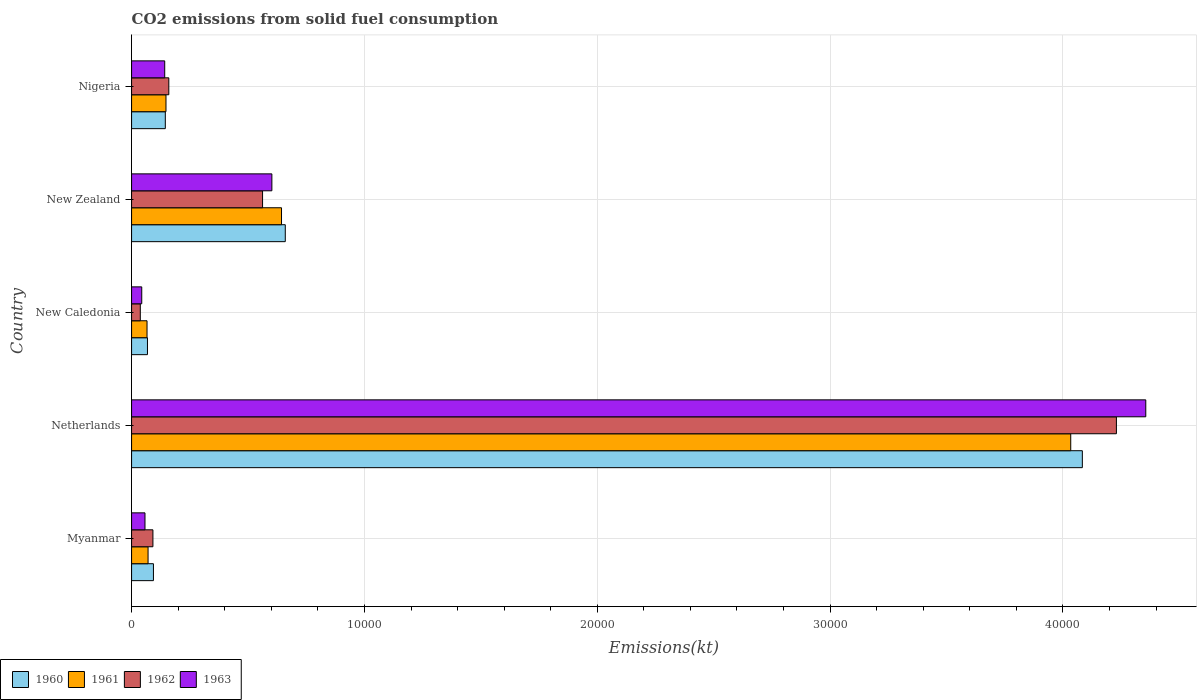How many groups of bars are there?
Keep it short and to the point. 5. How many bars are there on the 4th tick from the top?
Offer a very short reply. 4. What is the label of the 5th group of bars from the top?
Make the answer very short. Myanmar. In how many cases, is the number of bars for a given country not equal to the number of legend labels?
Offer a terse response. 0. What is the amount of CO2 emitted in 1961 in Nigeria?
Offer a very short reply. 1477.8. Across all countries, what is the maximum amount of CO2 emitted in 1963?
Your answer should be very brief. 4.36e+04. Across all countries, what is the minimum amount of CO2 emitted in 1960?
Make the answer very short. 682.06. In which country was the amount of CO2 emitted in 1962 maximum?
Offer a very short reply. Netherlands. In which country was the amount of CO2 emitted in 1960 minimum?
Make the answer very short. New Caledonia. What is the total amount of CO2 emitted in 1961 in the graph?
Give a very brief answer. 4.96e+04. What is the difference between the amount of CO2 emitted in 1962 in New Caledonia and that in New Zealand?
Provide a short and direct response. -5251.14. What is the difference between the amount of CO2 emitted in 1961 in Netherlands and the amount of CO2 emitted in 1960 in New Caledonia?
Ensure brevity in your answer.  3.97e+04. What is the average amount of CO2 emitted in 1961 per country?
Ensure brevity in your answer.  9924.37. What is the difference between the amount of CO2 emitted in 1962 and amount of CO2 emitted in 1961 in New Zealand?
Offer a terse response. -814.07. What is the ratio of the amount of CO2 emitted in 1961 in Netherlands to that in Nigeria?
Keep it short and to the point. 27.29. What is the difference between the highest and the second highest amount of CO2 emitted in 1961?
Your answer should be compact. 3.39e+04. What is the difference between the highest and the lowest amount of CO2 emitted in 1961?
Your answer should be very brief. 3.97e+04. In how many countries, is the amount of CO2 emitted in 1962 greater than the average amount of CO2 emitted in 1962 taken over all countries?
Make the answer very short. 1. Is the sum of the amount of CO2 emitted in 1960 in Netherlands and Nigeria greater than the maximum amount of CO2 emitted in 1961 across all countries?
Provide a short and direct response. Yes. Is it the case that in every country, the sum of the amount of CO2 emitted in 1963 and amount of CO2 emitted in 1960 is greater than the sum of amount of CO2 emitted in 1962 and amount of CO2 emitted in 1961?
Offer a very short reply. No. What does the 3rd bar from the bottom in New Zealand represents?
Give a very brief answer. 1962. What is the difference between two consecutive major ticks on the X-axis?
Ensure brevity in your answer.  10000. Does the graph contain any zero values?
Give a very brief answer. No. Where does the legend appear in the graph?
Your answer should be very brief. Bottom left. What is the title of the graph?
Make the answer very short. CO2 emissions from solid fuel consumption. Does "1987" appear as one of the legend labels in the graph?
Make the answer very short. No. What is the label or title of the X-axis?
Your answer should be very brief. Emissions(kt). What is the Emissions(kt) of 1960 in Myanmar?
Your response must be concise. 938.75. What is the Emissions(kt) in 1961 in Myanmar?
Ensure brevity in your answer.  707.73. What is the Emissions(kt) in 1962 in Myanmar?
Offer a very short reply. 916.75. What is the Emissions(kt) of 1963 in Myanmar?
Ensure brevity in your answer.  575.72. What is the Emissions(kt) in 1960 in Netherlands?
Keep it short and to the point. 4.08e+04. What is the Emissions(kt) in 1961 in Netherlands?
Make the answer very short. 4.03e+04. What is the Emissions(kt) of 1962 in Netherlands?
Your answer should be very brief. 4.23e+04. What is the Emissions(kt) in 1963 in Netherlands?
Your answer should be compact. 4.36e+04. What is the Emissions(kt) in 1960 in New Caledonia?
Provide a succinct answer. 682.06. What is the Emissions(kt) of 1961 in New Caledonia?
Offer a terse response. 663.73. What is the Emissions(kt) of 1962 in New Caledonia?
Keep it short and to the point. 374.03. What is the Emissions(kt) in 1963 in New Caledonia?
Your answer should be compact. 436.37. What is the Emissions(kt) of 1960 in New Zealand?
Provide a short and direct response. 6600.6. What is the Emissions(kt) in 1961 in New Zealand?
Your answer should be compact. 6439.25. What is the Emissions(kt) in 1962 in New Zealand?
Keep it short and to the point. 5625.18. What is the Emissions(kt) of 1963 in New Zealand?
Your answer should be compact. 6024.88. What is the Emissions(kt) in 1960 in Nigeria?
Give a very brief answer. 1448.46. What is the Emissions(kt) of 1961 in Nigeria?
Your response must be concise. 1477.8. What is the Emissions(kt) of 1962 in Nigeria?
Give a very brief answer. 1598.81. What is the Emissions(kt) of 1963 in Nigeria?
Give a very brief answer. 1422.8. Across all countries, what is the maximum Emissions(kt) in 1960?
Your response must be concise. 4.08e+04. Across all countries, what is the maximum Emissions(kt) in 1961?
Provide a short and direct response. 4.03e+04. Across all countries, what is the maximum Emissions(kt) of 1962?
Your response must be concise. 4.23e+04. Across all countries, what is the maximum Emissions(kt) of 1963?
Your answer should be compact. 4.36e+04. Across all countries, what is the minimum Emissions(kt) of 1960?
Offer a very short reply. 682.06. Across all countries, what is the minimum Emissions(kt) in 1961?
Provide a succinct answer. 663.73. Across all countries, what is the minimum Emissions(kt) in 1962?
Give a very brief answer. 374.03. Across all countries, what is the minimum Emissions(kt) in 1963?
Offer a very short reply. 436.37. What is the total Emissions(kt) of 1960 in the graph?
Keep it short and to the point. 5.05e+04. What is the total Emissions(kt) of 1961 in the graph?
Make the answer very short. 4.96e+04. What is the total Emissions(kt) of 1962 in the graph?
Give a very brief answer. 5.08e+04. What is the total Emissions(kt) in 1963 in the graph?
Provide a succinct answer. 5.20e+04. What is the difference between the Emissions(kt) of 1960 in Myanmar and that in Netherlands?
Ensure brevity in your answer.  -3.99e+04. What is the difference between the Emissions(kt) in 1961 in Myanmar and that in Netherlands?
Your answer should be compact. -3.96e+04. What is the difference between the Emissions(kt) of 1962 in Myanmar and that in Netherlands?
Offer a very short reply. -4.14e+04. What is the difference between the Emissions(kt) in 1963 in Myanmar and that in Netherlands?
Give a very brief answer. -4.30e+04. What is the difference between the Emissions(kt) of 1960 in Myanmar and that in New Caledonia?
Provide a succinct answer. 256.69. What is the difference between the Emissions(kt) of 1961 in Myanmar and that in New Caledonia?
Your answer should be compact. 44. What is the difference between the Emissions(kt) in 1962 in Myanmar and that in New Caledonia?
Your response must be concise. 542.72. What is the difference between the Emissions(kt) of 1963 in Myanmar and that in New Caledonia?
Provide a succinct answer. 139.35. What is the difference between the Emissions(kt) of 1960 in Myanmar and that in New Zealand?
Your answer should be very brief. -5661.85. What is the difference between the Emissions(kt) of 1961 in Myanmar and that in New Zealand?
Give a very brief answer. -5731.52. What is the difference between the Emissions(kt) in 1962 in Myanmar and that in New Zealand?
Make the answer very short. -4708.43. What is the difference between the Emissions(kt) of 1963 in Myanmar and that in New Zealand?
Your response must be concise. -5449.16. What is the difference between the Emissions(kt) in 1960 in Myanmar and that in Nigeria?
Keep it short and to the point. -509.71. What is the difference between the Emissions(kt) of 1961 in Myanmar and that in Nigeria?
Keep it short and to the point. -770.07. What is the difference between the Emissions(kt) in 1962 in Myanmar and that in Nigeria?
Keep it short and to the point. -682.06. What is the difference between the Emissions(kt) in 1963 in Myanmar and that in Nigeria?
Give a very brief answer. -847.08. What is the difference between the Emissions(kt) of 1960 in Netherlands and that in New Caledonia?
Ensure brevity in your answer.  4.01e+04. What is the difference between the Emissions(kt) in 1961 in Netherlands and that in New Caledonia?
Offer a terse response. 3.97e+04. What is the difference between the Emissions(kt) of 1962 in Netherlands and that in New Caledonia?
Give a very brief answer. 4.19e+04. What is the difference between the Emissions(kt) of 1963 in Netherlands and that in New Caledonia?
Your answer should be very brief. 4.31e+04. What is the difference between the Emissions(kt) in 1960 in Netherlands and that in New Zealand?
Provide a succinct answer. 3.42e+04. What is the difference between the Emissions(kt) in 1961 in Netherlands and that in New Zealand?
Your response must be concise. 3.39e+04. What is the difference between the Emissions(kt) in 1962 in Netherlands and that in New Zealand?
Your answer should be compact. 3.67e+04. What is the difference between the Emissions(kt) of 1963 in Netherlands and that in New Zealand?
Keep it short and to the point. 3.75e+04. What is the difference between the Emissions(kt) of 1960 in Netherlands and that in Nigeria?
Your answer should be compact. 3.94e+04. What is the difference between the Emissions(kt) in 1961 in Netherlands and that in Nigeria?
Give a very brief answer. 3.89e+04. What is the difference between the Emissions(kt) of 1962 in Netherlands and that in Nigeria?
Ensure brevity in your answer.  4.07e+04. What is the difference between the Emissions(kt) in 1963 in Netherlands and that in Nigeria?
Your response must be concise. 4.21e+04. What is the difference between the Emissions(kt) of 1960 in New Caledonia and that in New Zealand?
Your response must be concise. -5918.54. What is the difference between the Emissions(kt) in 1961 in New Caledonia and that in New Zealand?
Provide a short and direct response. -5775.52. What is the difference between the Emissions(kt) in 1962 in New Caledonia and that in New Zealand?
Make the answer very short. -5251.14. What is the difference between the Emissions(kt) of 1963 in New Caledonia and that in New Zealand?
Your answer should be compact. -5588.51. What is the difference between the Emissions(kt) of 1960 in New Caledonia and that in Nigeria?
Offer a very short reply. -766.4. What is the difference between the Emissions(kt) of 1961 in New Caledonia and that in Nigeria?
Keep it short and to the point. -814.07. What is the difference between the Emissions(kt) in 1962 in New Caledonia and that in Nigeria?
Your answer should be very brief. -1224.78. What is the difference between the Emissions(kt) of 1963 in New Caledonia and that in Nigeria?
Provide a short and direct response. -986.42. What is the difference between the Emissions(kt) in 1960 in New Zealand and that in Nigeria?
Provide a succinct answer. 5152.14. What is the difference between the Emissions(kt) of 1961 in New Zealand and that in Nigeria?
Keep it short and to the point. 4961.45. What is the difference between the Emissions(kt) in 1962 in New Zealand and that in Nigeria?
Ensure brevity in your answer.  4026.37. What is the difference between the Emissions(kt) of 1963 in New Zealand and that in Nigeria?
Ensure brevity in your answer.  4602.09. What is the difference between the Emissions(kt) of 1960 in Myanmar and the Emissions(kt) of 1961 in Netherlands?
Give a very brief answer. -3.94e+04. What is the difference between the Emissions(kt) in 1960 in Myanmar and the Emissions(kt) in 1962 in Netherlands?
Make the answer very short. -4.14e+04. What is the difference between the Emissions(kt) of 1960 in Myanmar and the Emissions(kt) of 1963 in Netherlands?
Provide a succinct answer. -4.26e+04. What is the difference between the Emissions(kt) in 1961 in Myanmar and the Emissions(kt) in 1962 in Netherlands?
Provide a short and direct response. -4.16e+04. What is the difference between the Emissions(kt) in 1961 in Myanmar and the Emissions(kt) in 1963 in Netherlands?
Your answer should be very brief. -4.28e+04. What is the difference between the Emissions(kt) in 1962 in Myanmar and the Emissions(kt) in 1963 in Netherlands?
Provide a succinct answer. -4.26e+04. What is the difference between the Emissions(kt) in 1960 in Myanmar and the Emissions(kt) in 1961 in New Caledonia?
Your answer should be very brief. 275.02. What is the difference between the Emissions(kt) in 1960 in Myanmar and the Emissions(kt) in 1962 in New Caledonia?
Provide a short and direct response. 564.72. What is the difference between the Emissions(kt) of 1960 in Myanmar and the Emissions(kt) of 1963 in New Caledonia?
Give a very brief answer. 502.38. What is the difference between the Emissions(kt) in 1961 in Myanmar and the Emissions(kt) in 1962 in New Caledonia?
Keep it short and to the point. 333.7. What is the difference between the Emissions(kt) of 1961 in Myanmar and the Emissions(kt) of 1963 in New Caledonia?
Make the answer very short. 271.36. What is the difference between the Emissions(kt) in 1962 in Myanmar and the Emissions(kt) in 1963 in New Caledonia?
Give a very brief answer. 480.38. What is the difference between the Emissions(kt) in 1960 in Myanmar and the Emissions(kt) in 1961 in New Zealand?
Keep it short and to the point. -5500.5. What is the difference between the Emissions(kt) of 1960 in Myanmar and the Emissions(kt) of 1962 in New Zealand?
Offer a very short reply. -4686.43. What is the difference between the Emissions(kt) in 1960 in Myanmar and the Emissions(kt) in 1963 in New Zealand?
Your answer should be very brief. -5086.13. What is the difference between the Emissions(kt) in 1961 in Myanmar and the Emissions(kt) in 1962 in New Zealand?
Offer a terse response. -4917.45. What is the difference between the Emissions(kt) in 1961 in Myanmar and the Emissions(kt) in 1963 in New Zealand?
Make the answer very short. -5317.15. What is the difference between the Emissions(kt) of 1962 in Myanmar and the Emissions(kt) of 1963 in New Zealand?
Your answer should be very brief. -5108.13. What is the difference between the Emissions(kt) of 1960 in Myanmar and the Emissions(kt) of 1961 in Nigeria?
Ensure brevity in your answer.  -539.05. What is the difference between the Emissions(kt) of 1960 in Myanmar and the Emissions(kt) of 1962 in Nigeria?
Your answer should be very brief. -660.06. What is the difference between the Emissions(kt) of 1960 in Myanmar and the Emissions(kt) of 1963 in Nigeria?
Your response must be concise. -484.04. What is the difference between the Emissions(kt) of 1961 in Myanmar and the Emissions(kt) of 1962 in Nigeria?
Provide a short and direct response. -891.08. What is the difference between the Emissions(kt) in 1961 in Myanmar and the Emissions(kt) in 1963 in Nigeria?
Keep it short and to the point. -715.07. What is the difference between the Emissions(kt) of 1962 in Myanmar and the Emissions(kt) of 1963 in Nigeria?
Provide a short and direct response. -506.05. What is the difference between the Emissions(kt) in 1960 in Netherlands and the Emissions(kt) in 1961 in New Caledonia?
Make the answer very short. 4.02e+04. What is the difference between the Emissions(kt) in 1960 in Netherlands and the Emissions(kt) in 1962 in New Caledonia?
Your answer should be compact. 4.05e+04. What is the difference between the Emissions(kt) of 1960 in Netherlands and the Emissions(kt) of 1963 in New Caledonia?
Your answer should be very brief. 4.04e+04. What is the difference between the Emissions(kt) of 1961 in Netherlands and the Emissions(kt) of 1962 in New Caledonia?
Offer a terse response. 4.00e+04. What is the difference between the Emissions(kt) in 1961 in Netherlands and the Emissions(kt) in 1963 in New Caledonia?
Your answer should be compact. 3.99e+04. What is the difference between the Emissions(kt) in 1962 in Netherlands and the Emissions(kt) in 1963 in New Caledonia?
Offer a very short reply. 4.19e+04. What is the difference between the Emissions(kt) of 1960 in Netherlands and the Emissions(kt) of 1961 in New Zealand?
Keep it short and to the point. 3.44e+04. What is the difference between the Emissions(kt) of 1960 in Netherlands and the Emissions(kt) of 1962 in New Zealand?
Keep it short and to the point. 3.52e+04. What is the difference between the Emissions(kt) in 1960 in Netherlands and the Emissions(kt) in 1963 in New Zealand?
Your answer should be very brief. 3.48e+04. What is the difference between the Emissions(kt) in 1961 in Netherlands and the Emissions(kt) in 1962 in New Zealand?
Give a very brief answer. 3.47e+04. What is the difference between the Emissions(kt) in 1961 in Netherlands and the Emissions(kt) in 1963 in New Zealand?
Provide a succinct answer. 3.43e+04. What is the difference between the Emissions(kt) of 1962 in Netherlands and the Emissions(kt) of 1963 in New Zealand?
Make the answer very short. 3.63e+04. What is the difference between the Emissions(kt) in 1960 in Netherlands and the Emissions(kt) in 1961 in Nigeria?
Make the answer very short. 3.94e+04. What is the difference between the Emissions(kt) in 1960 in Netherlands and the Emissions(kt) in 1962 in Nigeria?
Ensure brevity in your answer.  3.92e+04. What is the difference between the Emissions(kt) in 1960 in Netherlands and the Emissions(kt) in 1963 in Nigeria?
Make the answer very short. 3.94e+04. What is the difference between the Emissions(kt) of 1961 in Netherlands and the Emissions(kt) of 1962 in Nigeria?
Make the answer very short. 3.87e+04. What is the difference between the Emissions(kt) of 1961 in Netherlands and the Emissions(kt) of 1963 in Nigeria?
Your answer should be very brief. 3.89e+04. What is the difference between the Emissions(kt) of 1962 in Netherlands and the Emissions(kt) of 1963 in Nigeria?
Your answer should be compact. 4.09e+04. What is the difference between the Emissions(kt) in 1960 in New Caledonia and the Emissions(kt) in 1961 in New Zealand?
Keep it short and to the point. -5757.19. What is the difference between the Emissions(kt) of 1960 in New Caledonia and the Emissions(kt) of 1962 in New Zealand?
Your answer should be compact. -4943.12. What is the difference between the Emissions(kt) of 1960 in New Caledonia and the Emissions(kt) of 1963 in New Zealand?
Keep it short and to the point. -5342.82. What is the difference between the Emissions(kt) in 1961 in New Caledonia and the Emissions(kt) in 1962 in New Zealand?
Provide a short and direct response. -4961.45. What is the difference between the Emissions(kt) of 1961 in New Caledonia and the Emissions(kt) of 1963 in New Zealand?
Your answer should be compact. -5361.15. What is the difference between the Emissions(kt) in 1962 in New Caledonia and the Emissions(kt) in 1963 in New Zealand?
Your answer should be compact. -5650.85. What is the difference between the Emissions(kt) in 1960 in New Caledonia and the Emissions(kt) in 1961 in Nigeria?
Offer a terse response. -795.74. What is the difference between the Emissions(kt) of 1960 in New Caledonia and the Emissions(kt) of 1962 in Nigeria?
Give a very brief answer. -916.75. What is the difference between the Emissions(kt) in 1960 in New Caledonia and the Emissions(kt) in 1963 in Nigeria?
Make the answer very short. -740.73. What is the difference between the Emissions(kt) in 1961 in New Caledonia and the Emissions(kt) in 1962 in Nigeria?
Provide a short and direct response. -935.09. What is the difference between the Emissions(kt) in 1961 in New Caledonia and the Emissions(kt) in 1963 in Nigeria?
Offer a terse response. -759.07. What is the difference between the Emissions(kt) in 1962 in New Caledonia and the Emissions(kt) in 1963 in Nigeria?
Offer a very short reply. -1048.76. What is the difference between the Emissions(kt) of 1960 in New Zealand and the Emissions(kt) of 1961 in Nigeria?
Keep it short and to the point. 5122.8. What is the difference between the Emissions(kt) in 1960 in New Zealand and the Emissions(kt) in 1962 in Nigeria?
Your answer should be compact. 5001.79. What is the difference between the Emissions(kt) of 1960 in New Zealand and the Emissions(kt) of 1963 in Nigeria?
Offer a terse response. 5177.8. What is the difference between the Emissions(kt) in 1961 in New Zealand and the Emissions(kt) in 1962 in Nigeria?
Offer a very short reply. 4840.44. What is the difference between the Emissions(kt) in 1961 in New Zealand and the Emissions(kt) in 1963 in Nigeria?
Your answer should be compact. 5016.46. What is the difference between the Emissions(kt) in 1962 in New Zealand and the Emissions(kt) in 1963 in Nigeria?
Your response must be concise. 4202.38. What is the average Emissions(kt) of 1960 per country?
Make the answer very short. 1.01e+04. What is the average Emissions(kt) in 1961 per country?
Ensure brevity in your answer.  9924.37. What is the average Emissions(kt) in 1962 per country?
Offer a terse response. 1.02e+04. What is the average Emissions(kt) of 1963 per country?
Offer a terse response. 1.04e+04. What is the difference between the Emissions(kt) in 1960 and Emissions(kt) in 1961 in Myanmar?
Your answer should be compact. 231.02. What is the difference between the Emissions(kt) in 1960 and Emissions(kt) in 1962 in Myanmar?
Your response must be concise. 22. What is the difference between the Emissions(kt) in 1960 and Emissions(kt) in 1963 in Myanmar?
Your answer should be compact. 363.03. What is the difference between the Emissions(kt) in 1961 and Emissions(kt) in 1962 in Myanmar?
Your answer should be compact. -209.02. What is the difference between the Emissions(kt) of 1961 and Emissions(kt) of 1963 in Myanmar?
Ensure brevity in your answer.  132.01. What is the difference between the Emissions(kt) of 1962 and Emissions(kt) of 1963 in Myanmar?
Ensure brevity in your answer.  341.03. What is the difference between the Emissions(kt) of 1960 and Emissions(kt) of 1961 in Netherlands?
Ensure brevity in your answer.  498.71. What is the difference between the Emissions(kt) in 1960 and Emissions(kt) in 1962 in Netherlands?
Your response must be concise. -1463.13. What is the difference between the Emissions(kt) in 1960 and Emissions(kt) in 1963 in Netherlands?
Give a very brief answer. -2724.58. What is the difference between the Emissions(kt) in 1961 and Emissions(kt) in 1962 in Netherlands?
Ensure brevity in your answer.  -1961.85. What is the difference between the Emissions(kt) in 1961 and Emissions(kt) in 1963 in Netherlands?
Your answer should be compact. -3223.29. What is the difference between the Emissions(kt) of 1962 and Emissions(kt) of 1963 in Netherlands?
Ensure brevity in your answer.  -1261.45. What is the difference between the Emissions(kt) of 1960 and Emissions(kt) of 1961 in New Caledonia?
Make the answer very short. 18.34. What is the difference between the Emissions(kt) of 1960 and Emissions(kt) of 1962 in New Caledonia?
Your answer should be very brief. 308.03. What is the difference between the Emissions(kt) in 1960 and Emissions(kt) in 1963 in New Caledonia?
Provide a succinct answer. 245.69. What is the difference between the Emissions(kt) in 1961 and Emissions(kt) in 1962 in New Caledonia?
Give a very brief answer. 289.69. What is the difference between the Emissions(kt) of 1961 and Emissions(kt) of 1963 in New Caledonia?
Your response must be concise. 227.35. What is the difference between the Emissions(kt) in 1962 and Emissions(kt) in 1963 in New Caledonia?
Make the answer very short. -62.34. What is the difference between the Emissions(kt) in 1960 and Emissions(kt) in 1961 in New Zealand?
Keep it short and to the point. 161.35. What is the difference between the Emissions(kt) in 1960 and Emissions(kt) in 1962 in New Zealand?
Keep it short and to the point. 975.42. What is the difference between the Emissions(kt) of 1960 and Emissions(kt) of 1963 in New Zealand?
Provide a succinct answer. 575.72. What is the difference between the Emissions(kt) in 1961 and Emissions(kt) in 1962 in New Zealand?
Offer a terse response. 814.07. What is the difference between the Emissions(kt) of 1961 and Emissions(kt) of 1963 in New Zealand?
Make the answer very short. 414.37. What is the difference between the Emissions(kt) of 1962 and Emissions(kt) of 1963 in New Zealand?
Your answer should be compact. -399.7. What is the difference between the Emissions(kt) in 1960 and Emissions(kt) in 1961 in Nigeria?
Your answer should be very brief. -29.34. What is the difference between the Emissions(kt) of 1960 and Emissions(kt) of 1962 in Nigeria?
Give a very brief answer. -150.35. What is the difference between the Emissions(kt) in 1960 and Emissions(kt) in 1963 in Nigeria?
Give a very brief answer. 25.67. What is the difference between the Emissions(kt) in 1961 and Emissions(kt) in 1962 in Nigeria?
Keep it short and to the point. -121.01. What is the difference between the Emissions(kt) in 1961 and Emissions(kt) in 1963 in Nigeria?
Make the answer very short. 55.01. What is the difference between the Emissions(kt) in 1962 and Emissions(kt) in 1963 in Nigeria?
Provide a short and direct response. 176.02. What is the ratio of the Emissions(kt) in 1960 in Myanmar to that in Netherlands?
Provide a succinct answer. 0.02. What is the ratio of the Emissions(kt) of 1961 in Myanmar to that in Netherlands?
Provide a succinct answer. 0.02. What is the ratio of the Emissions(kt) in 1962 in Myanmar to that in Netherlands?
Give a very brief answer. 0.02. What is the ratio of the Emissions(kt) in 1963 in Myanmar to that in Netherlands?
Your answer should be compact. 0.01. What is the ratio of the Emissions(kt) of 1960 in Myanmar to that in New Caledonia?
Your response must be concise. 1.38. What is the ratio of the Emissions(kt) of 1961 in Myanmar to that in New Caledonia?
Offer a terse response. 1.07. What is the ratio of the Emissions(kt) of 1962 in Myanmar to that in New Caledonia?
Give a very brief answer. 2.45. What is the ratio of the Emissions(kt) of 1963 in Myanmar to that in New Caledonia?
Offer a terse response. 1.32. What is the ratio of the Emissions(kt) of 1960 in Myanmar to that in New Zealand?
Give a very brief answer. 0.14. What is the ratio of the Emissions(kt) in 1961 in Myanmar to that in New Zealand?
Provide a short and direct response. 0.11. What is the ratio of the Emissions(kt) of 1962 in Myanmar to that in New Zealand?
Keep it short and to the point. 0.16. What is the ratio of the Emissions(kt) in 1963 in Myanmar to that in New Zealand?
Provide a succinct answer. 0.1. What is the ratio of the Emissions(kt) in 1960 in Myanmar to that in Nigeria?
Provide a short and direct response. 0.65. What is the ratio of the Emissions(kt) of 1961 in Myanmar to that in Nigeria?
Keep it short and to the point. 0.48. What is the ratio of the Emissions(kt) of 1962 in Myanmar to that in Nigeria?
Your answer should be compact. 0.57. What is the ratio of the Emissions(kt) of 1963 in Myanmar to that in Nigeria?
Your answer should be compact. 0.4. What is the ratio of the Emissions(kt) in 1960 in Netherlands to that in New Caledonia?
Offer a very short reply. 59.87. What is the ratio of the Emissions(kt) in 1961 in Netherlands to that in New Caledonia?
Make the answer very short. 60.77. What is the ratio of the Emissions(kt) of 1962 in Netherlands to that in New Caledonia?
Give a very brief answer. 113.08. What is the ratio of the Emissions(kt) in 1963 in Netherlands to that in New Caledonia?
Provide a short and direct response. 99.82. What is the ratio of the Emissions(kt) of 1960 in Netherlands to that in New Zealand?
Provide a short and direct response. 6.19. What is the ratio of the Emissions(kt) in 1961 in Netherlands to that in New Zealand?
Ensure brevity in your answer.  6.26. What is the ratio of the Emissions(kt) of 1962 in Netherlands to that in New Zealand?
Provide a short and direct response. 7.52. What is the ratio of the Emissions(kt) in 1963 in Netherlands to that in New Zealand?
Make the answer very short. 7.23. What is the ratio of the Emissions(kt) of 1960 in Netherlands to that in Nigeria?
Provide a succinct answer. 28.19. What is the ratio of the Emissions(kt) in 1961 in Netherlands to that in Nigeria?
Offer a terse response. 27.29. What is the ratio of the Emissions(kt) of 1962 in Netherlands to that in Nigeria?
Offer a terse response. 26.45. What is the ratio of the Emissions(kt) in 1963 in Netherlands to that in Nigeria?
Give a very brief answer. 30.61. What is the ratio of the Emissions(kt) of 1960 in New Caledonia to that in New Zealand?
Offer a very short reply. 0.1. What is the ratio of the Emissions(kt) of 1961 in New Caledonia to that in New Zealand?
Provide a short and direct response. 0.1. What is the ratio of the Emissions(kt) of 1962 in New Caledonia to that in New Zealand?
Offer a very short reply. 0.07. What is the ratio of the Emissions(kt) in 1963 in New Caledonia to that in New Zealand?
Give a very brief answer. 0.07. What is the ratio of the Emissions(kt) in 1960 in New Caledonia to that in Nigeria?
Your response must be concise. 0.47. What is the ratio of the Emissions(kt) of 1961 in New Caledonia to that in Nigeria?
Make the answer very short. 0.45. What is the ratio of the Emissions(kt) of 1962 in New Caledonia to that in Nigeria?
Offer a very short reply. 0.23. What is the ratio of the Emissions(kt) in 1963 in New Caledonia to that in Nigeria?
Ensure brevity in your answer.  0.31. What is the ratio of the Emissions(kt) of 1960 in New Zealand to that in Nigeria?
Provide a short and direct response. 4.56. What is the ratio of the Emissions(kt) of 1961 in New Zealand to that in Nigeria?
Offer a terse response. 4.36. What is the ratio of the Emissions(kt) of 1962 in New Zealand to that in Nigeria?
Your answer should be compact. 3.52. What is the ratio of the Emissions(kt) in 1963 in New Zealand to that in Nigeria?
Give a very brief answer. 4.23. What is the difference between the highest and the second highest Emissions(kt) of 1960?
Offer a very short reply. 3.42e+04. What is the difference between the highest and the second highest Emissions(kt) in 1961?
Your answer should be very brief. 3.39e+04. What is the difference between the highest and the second highest Emissions(kt) of 1962?
Keep it short and to the point. 3.67e+04. What is the difference between the highest and the second highest Emissions(kt) of 1963?
Offer a very short reply. 3.75e+04. What is the difference between the highest and the lowest Emissions(kt) of 1960?
Provide a succinct answer. 4.01e+04. What is the difference between the highest and the lowest Emissions(kt) in 1961?
Provide a short and direct response. 3.97e+04. What is the difference between the highest and the lowest Emissions(kt) in 1962?
Your answer should be very brief. 4.19e+04. What is the difference between the highest and the lowest Emissions(kt) of 1963?
Your answer should be compact. 4.31e+04. 